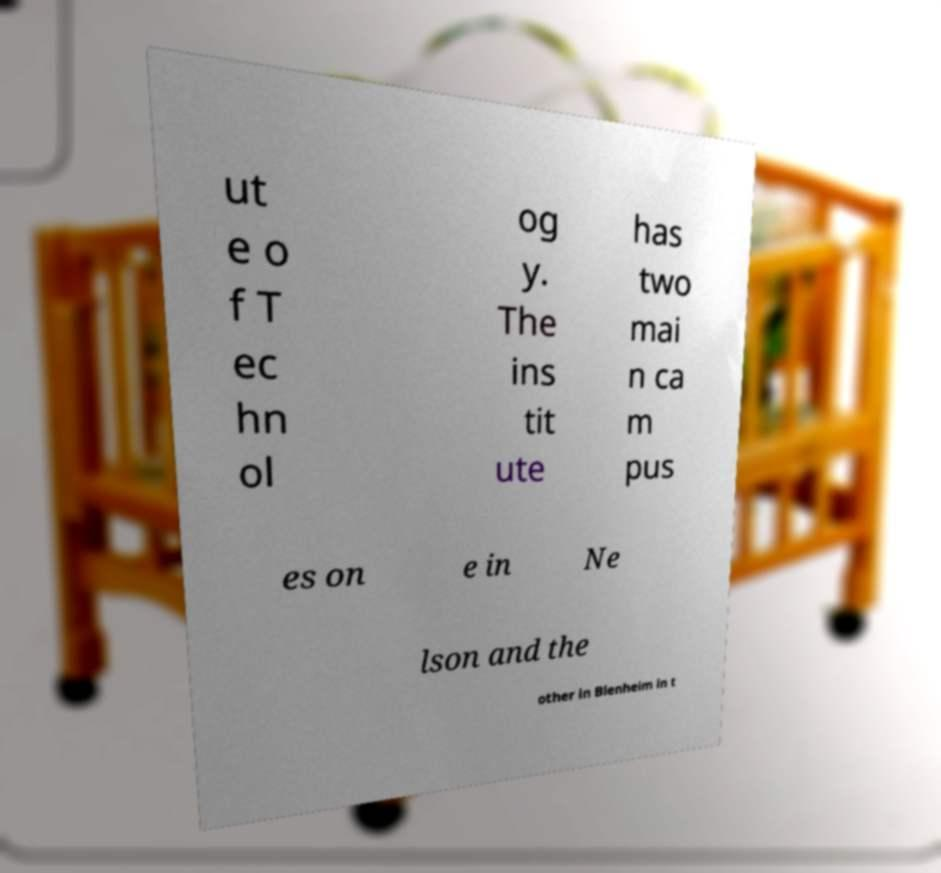There's text embedded in this image that I need extracted. Can you transcribe it verbatim? ut e o f T ec hn ol og y. The ins tit ute has two mai n ca m pus es on e in Ne lson and the other in Blenheim in t 